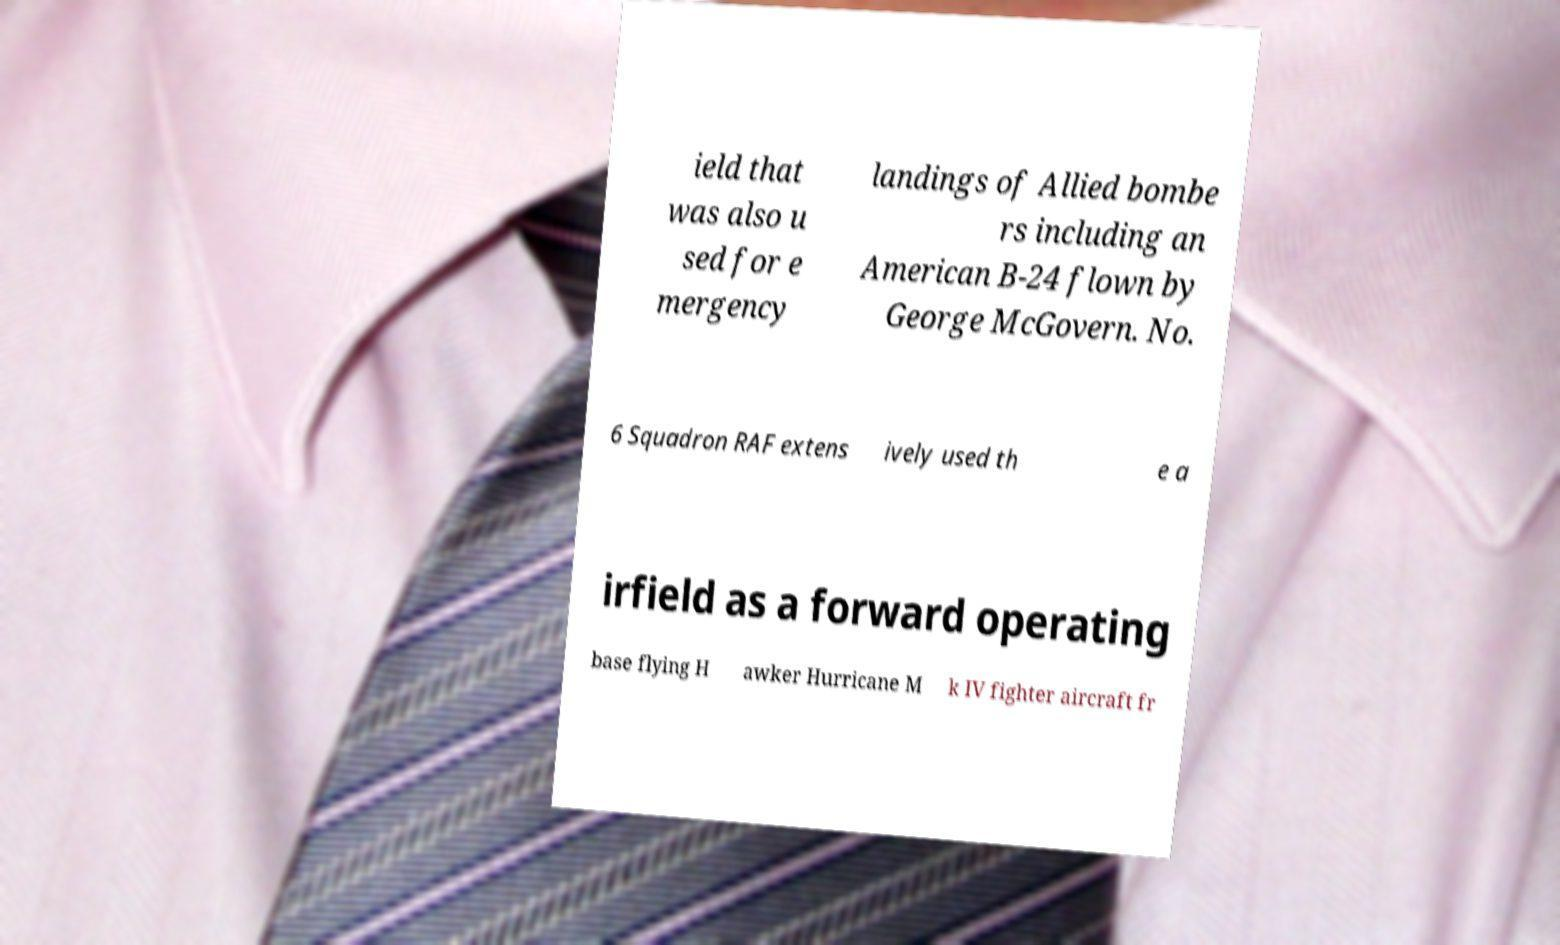Please identify and transcribe the text found in this image. ield that was also u sed for e mergency landings of Allied bombe rs including an American B-24 flown by George McGovern. No. 6 Squadron RAF extens ively used th e a irfield as a forward operating base flying H awker Hurricane M k IV fighter aircraft fr 